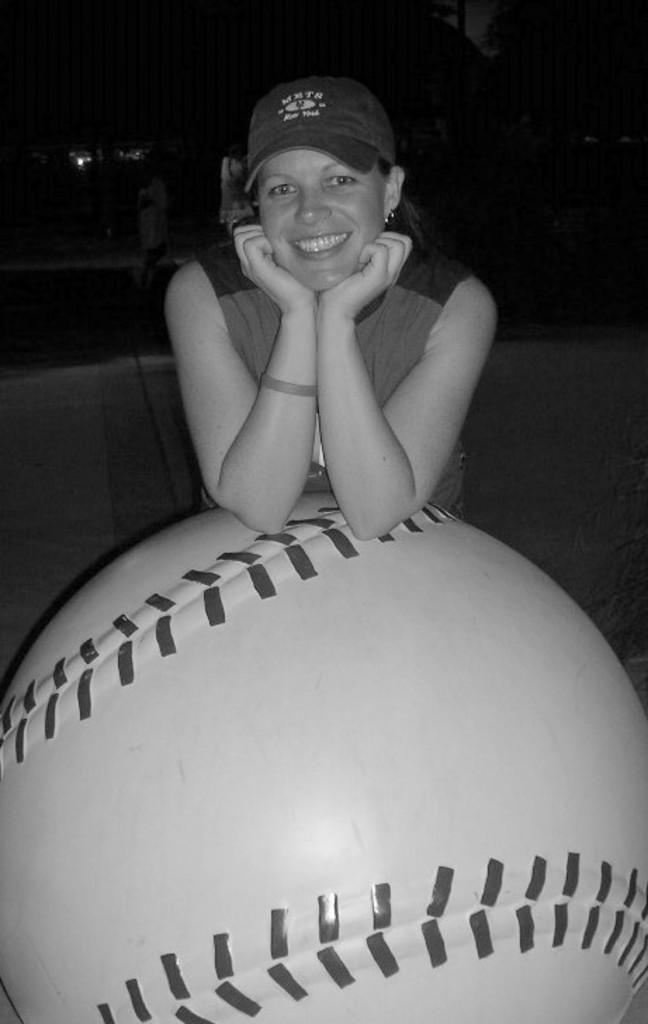Who is present in the image? There is a woman in the image. What is the woman wearing on her head? The woman is wearing a hat. What type of clothing is the woman wearing? The woman is wearing a dress. What is the woman's facial expression? The woman is smiling. What is the woman holding in the image? The woman has her hands on a huge ball. What colors can be seen on the huge ball? The huge ball is white and black in color. How would you describe the lighting in the image? The background of the image is dark. Can you see any rats interacting with the woman in the image? There are no rats present in the image. What type of bone is visible in the woman's hand? There is no bone visible in the image; the woman is holding a huge white and black ball. 